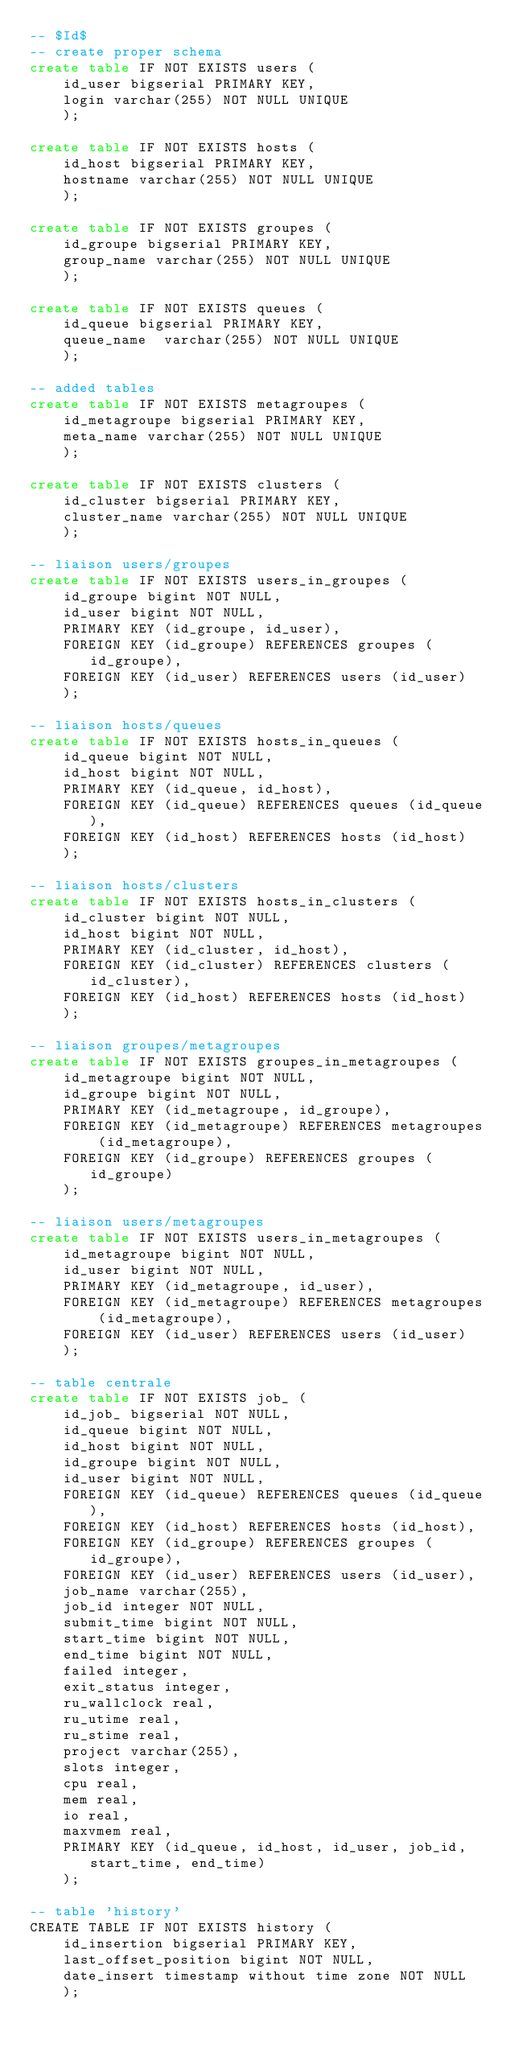Convert code to text. <code><loc_0><loc_0><loc_500><loc_500><_SQL_>-- $Id$
-- create proper schema
create table IF NOT EXISTS users (
    id_user bigserial PRIMARY KEY,
    login varchar(255) NOT NULL UNIQUE
    );

create table IF NOT EXISTS hosts (
    id_host bigserial PRIMARY KEY,
    hostname varchar(255) NOT NULL UNIQUE
    );

create table IF NOT EXISTS groupes (
    id_groupe bigserial PRIMARY KEY,
    group_name varchar(255) NOT NULL UNIQUE
    );

create table IF NOT EXISTS queues (
    id_queue bigserial PRIMARY KEY,
    queue_name  varchar(255) NOT NULL UNIQUE
    );

-- added tables
create table IF NOT EXISTS metagroupes (
    id_metagroupe bigserial PRIMARY KEY,
    meta_name varchar(255) NOT NULL UNIQUE
    );

create table IF NOT EXISTS clusters (
    id_cluster bigserial PRIMARY KEY,
    cluster_name varchar(255) NOT NULL UNIQUE
    );

-- liaison users/groupes
create table IF NOT EXISTS users_in_groupes (
    id_groupe bigint NOT NULL,
    id_user bigint NOT NULL,
    PRIMARY KEY (id_groupe, id_user),
    FOREIGN KEY (id_groupe) REFERENCES groupes (id_groupe),
    FOREIGN KEY (id_user) REFERENCES users (id_user)
    );

-- liaison hosts/queues
create table IF NOT EXISTS hosts_in_queues (
    id_queue bigint NOT NULL,
    id_host bigint NOT NULL,
    PRIMARY KEY (id_queue, id_host),
    FOREIGN KEY (id_queue) REFERENCES queues (id_queue),
    FOREIGN KEY (id_host) REFERENCES hosts (id_host)
    );

-- liaison hosts/clusters
create table IF NOT EXISTS hosts_in_clusters (
    id_cluster bigint NOT NULL,
    id_host bigint NOT NULL,
    PRIMARY KEY (id_cluster, id_host),
    FOREIGN KEY (id_cluster) REFERENCES clusters (id_cluster),
    FOREIGN KEY (id_host) REFERENCES hosts (id_host)
    );

-- liaison groupes/metagroupes
create table IF NOT EXISTS groupes_in_metagroupes (
    id_metagroupe bigint NOT NULL,
    id_groupe bigint NOT NULL,
    PRIMARY KEY (id_metagroupe, id_groupe),
    FOREIGN KEY (id_metagroupe) REFERENCES metagroupes (id_metagroupe),
    FOREIGN KEY (id_groupe) REFERENCES groupes (id_groupe)
    );

-- liaison users/metagroupes
create table IF NOT EXISTS users_in_metagroupes (
    id_metagroupe bigint NOT NULL,
    id_user bigint NOT NULL,
    PRIMARY KEY (id_metagroupe, id_user),
    FOREIGN KEY (id_metagroupe) REFERENCES metagroupes (id_metagroupe),
    FOREIGN KEY (id_user) REFERENCES users (id_user)
    );

-- table centrale
create table IF NOT EXISTS job_ (
    id_job_ bigserial NOT NULL,
    id_queue bigint NOT NULL,
    id_host bigint NOT NULL,
    id_groupe bigint NOT NULL,
    id_user bigint NOT NULL,
    FOREIGN KEY (id_queue) REFERENCES queues (id_queue),
    FOREIGN KEY (id_host) REFERENCES hosts (id_host),
    FOREIGN KEY (id_groupe) REFERENCES groupes (id_groupe),
    FOREIGN KEY (id_user) REFERENCES users (id_user),
    job_name varchar(255),
    job_id integer NOT NULL,
    submit_time bigint NOT NULL,
    start_time bigint NOT NULL,
    end_time bigint NOT NULL,
    failed integer,
    exit_status integer,
    ru_wallclock real,
    ru_utime real,
    ru_stime real,
    project varchar(255),
    slots integer,
    cpu real,
    mem real,
    io real,
    maxvmem real,
    PRIMARY KEY (id_queue, id_host, id_user, job_id, start_time, end_time)
    );

-- table 'history'
CREATE TABLE IF NOT EXISTS history (
    id_insertion bigserial PRIMARY KEY,
    last_offset_position bigint NOT NULL,
    date_insert timestamp without time zone NOT NULL
    );
</code> 